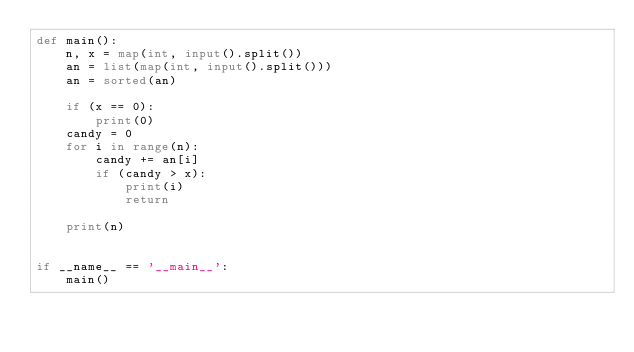Convert code to text. <code><loc_0><loc_0><loc_500><loc_500><_Python_>def main():
    n, x = map(int, input().split())
    an = list(map(int, input().split()))
    an = sorted(an)

    if (x == 0):
        print(0)
    candy = 0
    for i in range(n):
        candy += an[i]
        if (candy > x):
            print(i)
            return

    print(n)


if __name__ == '__main__':
    main()
</code> 